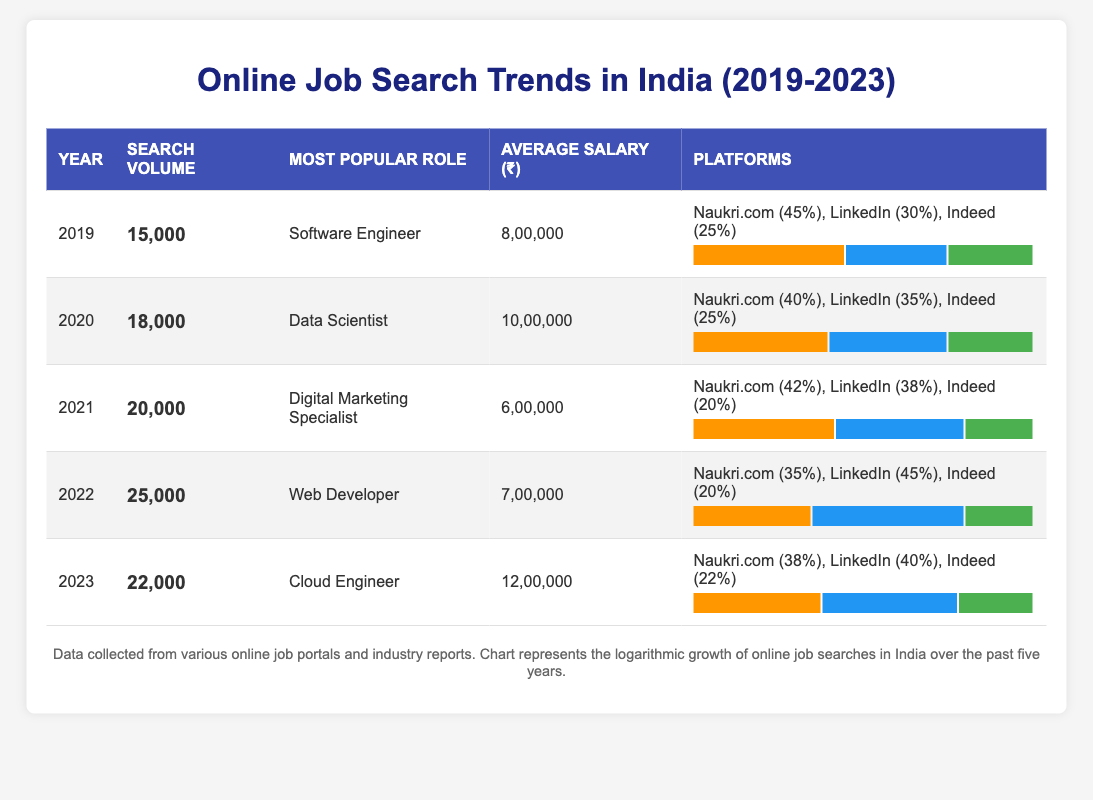What was the most popular job search role in 2021? The table lists the most popular roles for each year in the corresponding column. For 2021, the most popular role is "Digital Marketing Specialist."
Answer: Digital Marketing Specialist What was the average salary for a Data Scientist in 2020? The average salary for a Data Scientist in 2020 can be found in the row for that year, which states an average salary of 1,000,000.
Answer: 1,000,000 Which platform had the highest search volume percentage in 2022? In the row for 2022, the platforms and their search volume percentages are listed. LinkedIn has the highest percentage with 45%.
Answer: LinkedIn What is the total search volume from 2019 to 2023? To find the total search volume, add the search volumes from each year: 15,000 + 18,000 + 20,000 + 25,000 + 22,000 = 100,000.
Answer: 100,000 Did the average salary for Cloud Engineer increase or decrease from 2022 to 2023? The average salary for Cloud Engineer in 2022 was 700,000 and in 2023 it was 1,200,000. Since 1,200,000 is greater than 700,000, it increased.
Answer: Increased What was the search volume in 2020 compared to the search volume in 2021? The search volume in 2020 was 18,000, while in 2021 it was 20,000. 20,000 is greater than 18,000, indicating growth.
Answer: Increased Is it true that Naukri.com had the highest search volume percentage in 2023? In 2023, Naukri.com had a search volume percentage of 38%. LinkedIn had 40%, which is higher than Naukri.com, so the statement is false.
Answer: False What was the year with the lowest average salary? The average salaries for each year are: 800,000 (2019), 1,000,000 (2020), 600,000 (2021), 700,000 (2022), and 1,200,000 (2023). The lowest average salary is 600,000 in 2021.
Answer: 2021 Which year saw the highest search volume and what was that volume? The search volumes for each year are: 2019 - 15,000, 2020 - 18,000, 2021 - 20,000, 2022 - 25,000, and 2023 - 22,000. The highest search volume is 25,000 in 2022.
Answer: 25,000 What is the average salary across all five years? The average salary can be calculated by summing the average salaries: 800,000 + 1,000,000 + 600,000 + 700,000 + 1,200,000 = 3,300,000, and then dividing by 5, which results in 660,000.
Answer: 660,000 